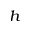Convert formula to latex. <formula><loc_0><loc_0><loc_500><loc_500>^ { h }</formula> 